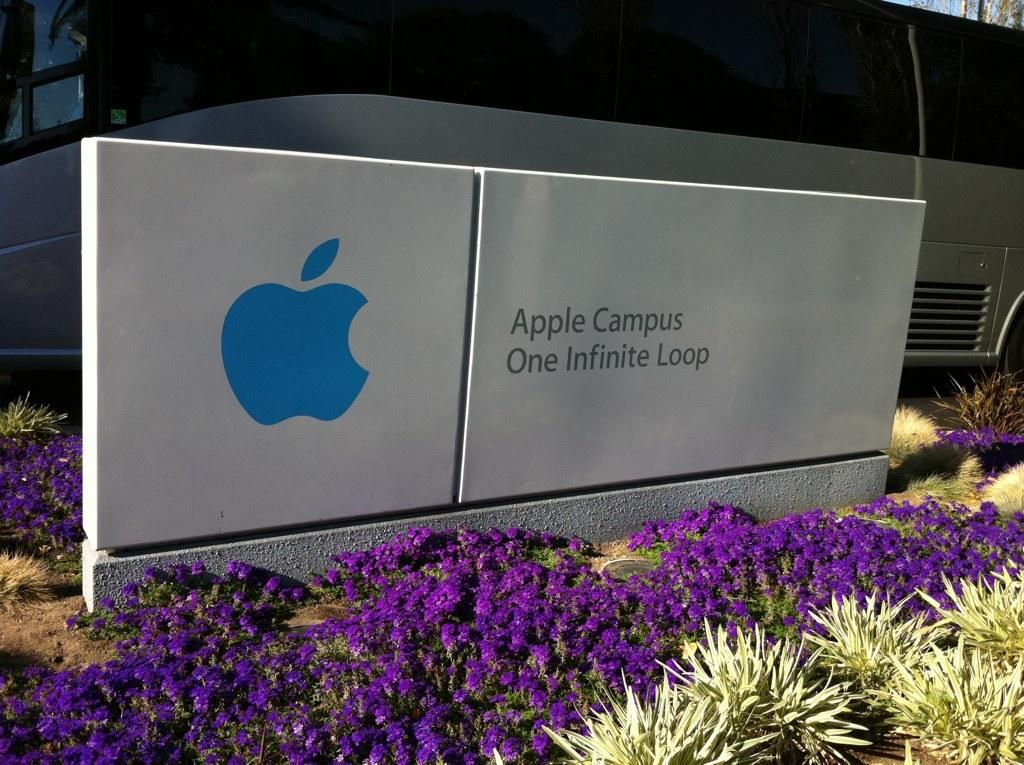What is depicted on the board in the image? There is an icon and text on the board in the image. What type of flora can be seen in the image? There are flowers and plants in the image. What mode of transportation is present in the image? There is a vehicle in the image. What can be seen in the background of the image? The sky is visible in the background of the image. What type of tongue can be seen sticking out of the vehicle in the image? There is no tongue visible in the image, and the vehicle does not have a tongue. 